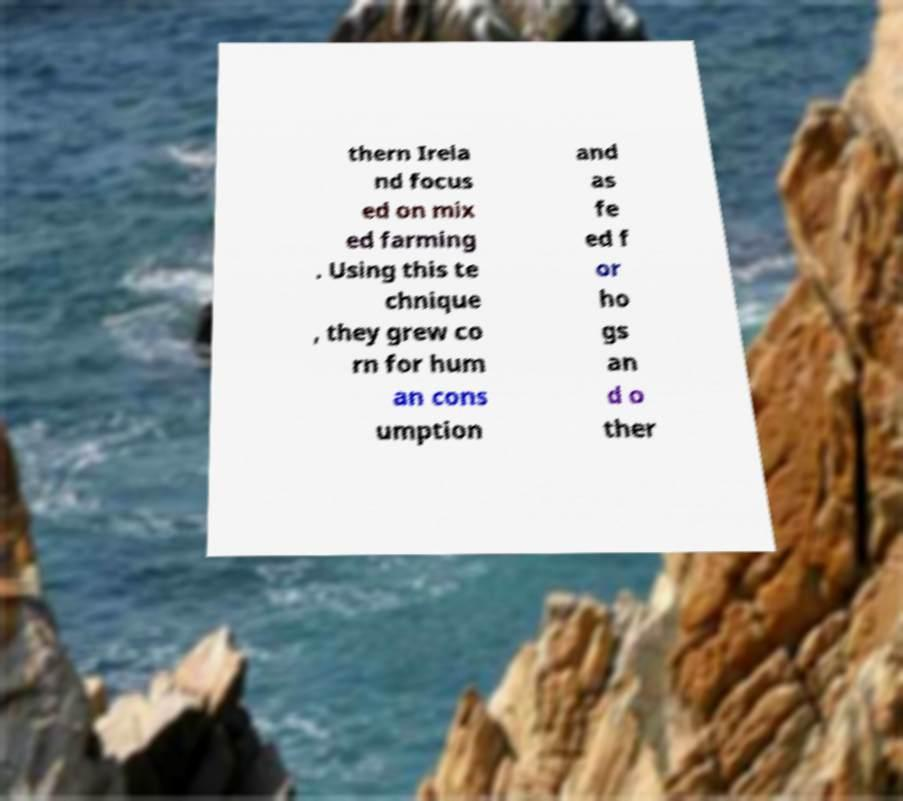I need the written content from this picture converted into text. Can you do that? thern Irela nd focus ed on mix ed farming . Using this te chnique , they grew co rn for hum an cons umption and as fe ed f or ho gs an d o ther 